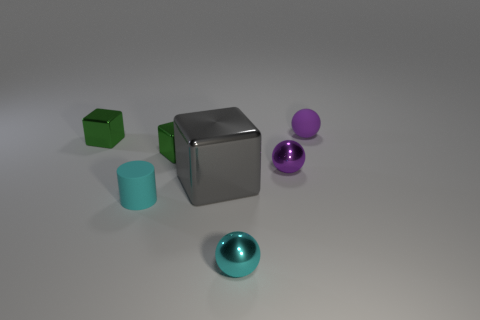There is a gray cube; does it have the same size as the purple ball that is left of the tiny rubber sphere?
Your response must be concise. No. There is a object that is in front of the tiny purple metallic ball and left of the big gray object; what shape is it?
Your answer should be compact. Cylinder. What number of big objects are either gray metal blocks or blue matte blocks?
Ensure brevity in your answer.  1. Are there the same number of tiny green cubes that are left of the tiny cyan cylinder and gray shiny objects behind the big shiny object?
Ensure brevity in your answer.  No. How many other things are there of the same color as the large metallic cube?
Your answer should be very brief. 0. Are there an equal number of big objects that are in front of the tiny cyan metal object and large gray things?
Keep it short and to the point. No. Is the size of the cyan shiny sphere the same as the cyan matte thing?
Give a very brief answer. Yes. What material is the object that is behind the purple metallic thing and on the right side of the tiny cyan sphere?
Provide a short and direct response. Rubber. How many other tiny objects are the same shape as the purple rubber thing?
Your answer should be compact. 2. What is the material of the cyan object left of the large shiny block?
Make the answer very short. Rubber. 